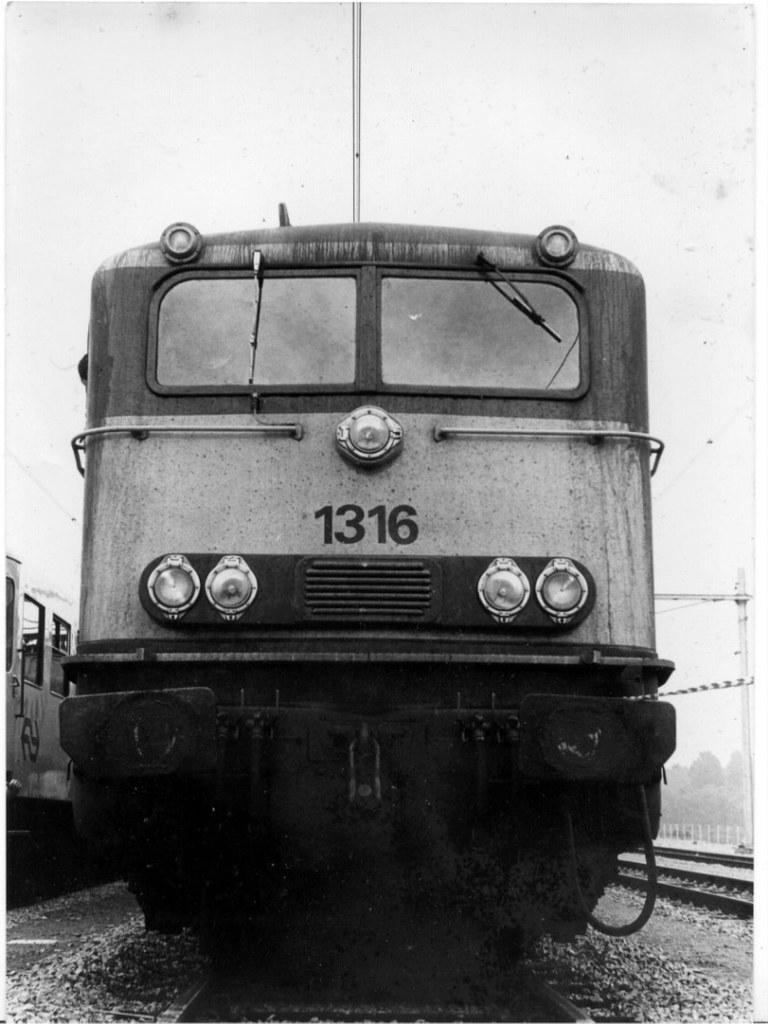What is the color scheme of the image? The image is black and white. What can be seen on the railway tracks in the image? There are trains on the railway tracks. What is visible in the background of the image? The sky is visible in the background of the image. What type of guitar is being played during the protest in the image? There is no guitar or protest present in the image; it features black and white trains on railway tracks with the sky visible in the background. 